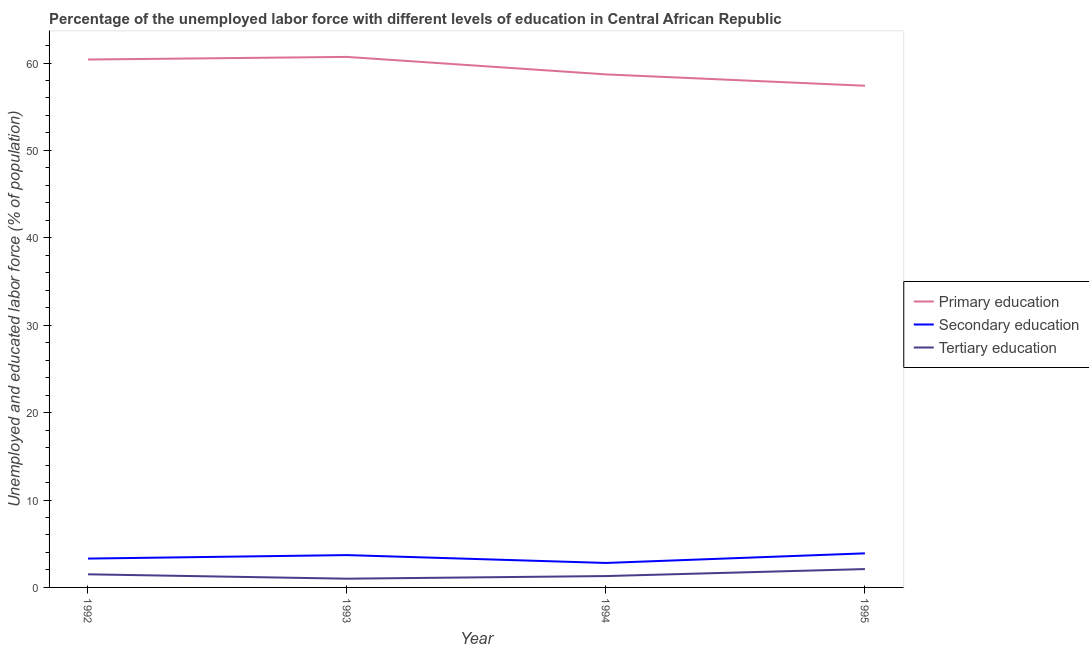Does the line corresponding to percentage of labor force who received tertiary education intersect with the line corresponding to percentage of labor force who received secondary education?
Your answer should be very brief. No. What is the percentage of labor force who received secondary education in 1994?
Give a very brief answer. 2.8. Across all years, what is the maximum percentage of labor force who received tertiary education?
Provide a short and direct response. 2.1. Across all years, what is the minimum percentage of labor force who received primary education?
Keep it short and to the point. 57.4. In which year was the percentage of labor force who received tertiary education maximum?
Ensure brevity in your answer.  1995. In which year was the percentage of labor force who received tertiary education minimum?
Your response must be concise. 1993. What is the total percentage of labor force who received primary education in the graph?
Your response must be concise. 237.2. What is the difference between the percentage of labor force who received primary education in 1993 and that in 1995?
Keep it short and to the point. 3.3. What is the difference between the percentage of labor force who received primary education in 1995 and the percentage of labor force who received tertiary education in 1994?
Provide a succinct answer. 56.1. What is the average percentage of labor force who received secondary education per year?
Provide a succinct answer. 3.43. In the year 1993, what is the difference between the percentage of labor force who received tertiary education and percentage of labor force who received secondary education?
Your answer should be very brief. -2.7. In how many years, is the percentage of labor force who received secondary education greater than 44 %?
Make the answer very short. 0. What is the ratio of the percentage of labor force who received primary education in 1994 to that in 1995?
Keep it short and to the point. 1.02. Is the percentage of labor force who received tertiary education in 1992 less than that in 1993?
Ensure brevity in your answer.  No. Is the difference between the percentage of labor force who received secondary education in 1994 and 1995 greater than the difference between the percentage of labor force who received tertiary education in 1994 and 1995?
Offer a very short reply. No. What is the difference between the highest and the second highest percentage of labor force who received secondary education?
Give a very brief answer. 0.2. What is the difference between the highest and the lowest percentage of labor force who received secondary education?
Provide a short and direct response. 1.1. Is the sum of the percentage of labor force who received secondary education in 1992 and 1995 greater than the maximum percentage of labor force who received tertiary education across all years?
Give a very brief answer. Yes. Is it the case that in every year, the sum of the percentage of labor force who received primary education and percentage of labor force who received secondary education is greater than the percentage of labor force who received tertiary education?
Give a very brief answer. Yes. Does the percentage of labor force who received primary education monotonically increase over the years?
Provide a short and direct response. No. Is the percentage of labor force who received secondary education strictly greater than the percentage of labor force who received tertiary education over the years?
Make the answer very short. Yes. Where does the legend appear in the graph?
Provide a succinct answer. Center right. How are the legend labels stacked?
Give a very brief answer. Vertical. What is the title of the graph?
Make the answer very short. Percentage of the unemployed labor force with different levels of education in Central African Republic. Does "Natural gas sources" appear as one of the legend labels in the graph?
Your response must be concise. No. What is the label or title of the X-axis?
Your response must be concise. Year. What is the label or title of the Y-axis?
Give a very brief answer. Unemployed and educated labor force (% of population). What is the Unemployed and educated labor force (% of population) in Primary education in 1992?
Provide a succinct answer. 60.4. What is the Unemployed and educated labor force (% of population) in Secondary education in 1992?
Provide a succinct answer. 3.3. What is the Unemployed and educated labor force (% of population) in Tertiary education in 1992?
Your answer should be very brief. 1.5. What is the Unemployed and educated labor force (% of population) in Primary education in 1993?
Give a very brief answer. 60.7. What is the Unemployed and educated labor force (% of population) in Secondary education in 1993?
Your response must be concise. 3.7. What is the Unemployed and educated labor force (% of population) of Primary education in 1994?
Ensure brevity in your answer.  58.7. What is the Unemployed and educated labor force (% of population) of Secondary education in 1994?
Offer a terse response. 2.8. What is the Unemployed and educated labor force (% of population) of Tertiary education in 1994?
Your answer should be compact. 1.3. What is the Unemployed and educated labor force (% of population) of Primary education in 1995?
Give a very brief answer. 57.4. What is the Unemployed and educated labor force (% of population) of Secondary education in 1995?
Offer a very short reply. 3.9. What is the Unemployed and educated labor force (% of population) in Tertiary education in 1995?
Your response must be concise. 2.1. Across all years, what is the maximum Unemployed and educated labor force (% of population) of Primary education?
Your answer should be very brief. 60.7. Across all years, what is the maximum Unemployed and educated labor force (% of population) in Secondary education?
Ensure brevity in your answer.  3.9. Across all years, what is the maximum Unemployed and educated labor force (% of population) of Tertiary education?
Give a very brief answer. 2.1. Across all years, what is the minimum Unemployed and educated labor force (% of population) in Primary education?
Provide a short and direct response. 57.4. Across all years, what is the minimum Unemployed and educated labor force (% of population) of Secondary education?
Make the answer very short. 2.8. What is the total Unemployed and educated labor force (% of population) of Primary education in the graph?
Make the answer very short. 237.2. What is the total Unemployed and educated labor force (% of population) in Secondary education in the graph?
Give a very brief answer. 13.7. What is the total Unemployed and educated labor force (% of population) in Tertiary education in the graph?
Offer a very short reply. 5.9. What is the difference between the Unemployed and educated labor force (% of population) in Primary education in 1992 and that in 1993?
Your answer should be compact. -0.3. What is the difference between the Unemployed and educated labor force (% of population) in Primary education in 1992 and that in 1995?
Your response must be concise. 3. What is the difference between the Unemployed and educated labor force (% of population) of Primary education in 1993 and that in 1994?
Your answer should be compact. 2. What is the difference between the Unemployed and educated labor force (% of population) of Tertiary education in 1993 and that in 1994?
Keep it short and to the point. -0.3. What is the difference between the Unemployed and educated labor force (% of population) in Primary education in 1993 and that in 1995?
Ensure brevity in your answer.  3.3. What is the difference between the Unemployed and educated labor force (% of population) of Secondary education in 1994 and that in 1995?
Your answer should be compact. -1.1. What is the difference between the Unemployed and educated labor force (% of population) of Primary education in 1992 and the Unemployed and educated labor force (% of population) of Secondary education in 1993?
Offer a very short reply. 56.7. What is the difference between the Unemployed and educated labor force (% of population) of Primary education in 1992 and the Unemployed and educated labor force (% of population) of Tertiary education in 1993?
Ensure brevity in your answer.  59.4. What is the difference between the Unemployed and educated labor force (% of population) of Secondary education in 1992 and the Unemployed and educated labor force (% of population) of Tertiary education in 1993?
Provide a short and direct response. 2.3. What is the difference between the Unemployed and educated labor force (% of population) in Primary education in 1992 and the Unemployed and educated labor force (% of population) in Secondary education in 1994?
Provide a succinct answer. 57.6. What is the difference between the Unemployed and educated labor force (% of population) of Primary education in 1992 and the Unemployed and educated labor force (% of population) of Tertiary education in 1994?
Give a very brief answer. 59.1. What is the difference between the Unemployed and educated labor force (% of population) of Secondary education in 1992 and the Unemployed and educated labor force (% of population) of Tertiary education in 1994?
Offer a terse response. 2. What is the difference between the Unemployed and educated labor force (% of population) in Primary education in 1992 and the Unemployed and educated labor force (% of population) in Secondary education in 1995?
Give a very brief answer. 56.5. What is the difference between the Unemployed and educated labor force (% of population) in Primary education in 1992 and the Unemployed and educated labor force (% of population) in Tertiary education in 1995?
Your answer should be compact. 58.3. What is the difference between the Unemployed and educated labor force (% of population) in Secondary education in 1992 and the Unemployed and educated labor force (% of population) in Tertiary education in 1995?
Provide a short and direct response. 1.2. What is the difference between the Unemployed and educated labor force (% of population) of Primary education in 1993 and the Unemployed and educated labor force (% of population) of Secondary education in 1994?
Offer a terse response. 57.9. What is the difference between the Unemployed and educated labor force (% of population) in Primary education in 1993 and the Unemployed and educated labor force (% of population) in Tertiary education in 1994?
Offer a very short reply. 59.4. What is the difference between the Unemployed and educated labor force (% of population) of Secondary education in 1993 and the Unemployed and educated labor force (% of population) of Tertiary education in 1994?
Offer a very short reply. 2.4. What is the difference between the Unemployed and educated labor force (% of population) of Primary education in 1993 and the Unemployed and educated labor force (% of population) of Secondary education in 1995?
Ensure brevity in your answer.  56.8. What is the difference between the Unemployed and educated labor force (% of population) of Primary education in 1993 and the Unemployed and educated labor force (% of population) of Tertiary education in 1995?
Make the answer very short. 58.6. What is the difference between the Unemployed and educated labor force (% of population) in Secondary education in 1993 and the Unemployed and educated labor force (% of population) in Tertiary education in 1995?
Offer a very short reply. 1.6. What is the difference between the Unemployed and educated labor force (% of population) in Primary education in 1994 and the Unemployed and educated labor force (% of population) in Secondary education in 1995?
Your answer should be very brief. 54.8. What is the difference between the Unemployed and educated labor force (% of population) of Primary education in 1994 and the Unemployed and educated labor force (% of population) of Tertiary education in 1995?
Make the answer very short. 56.6. What is the average Unemployed and educated labor force (% of population) in Primary education per year?
Your answer should be very brief. 59.3. What is the average Unemployed and educated labor force (% of population) in Secondary education per year?
Keep it short and to the point. 3.42. What is the average Unemployed and educated labor force (% of population) in Tertiary education per year?
Provide a succinct answer. 1.48. In the year 1992, what is the difference between the Unemployed and educated labor force (% of population) in Primary education and Unemployed and educated labor force (% of population) in Secondary education?
Provide a succinct answer. 57.1. In the year 1992, what is the difference between the Unemployed and educated labor force (% of population) of Primary education and Unemployed and educated labor force (% of population) of Tertiary education?
Offer a very short reply. 58.9. In the year 1992, what is the difference between the Unemployed and educated labor force (% of population) in Secondary education and Unemployed and educated labor force (% of population) in Tertiary education?
Your answer should be very brief. 1.8. In the year 1993, what is the difference between the Unemployed and educated labor force (% of population) of Primary education and Unemployed and educated labor force (% of population) of Secondary education?
Your answer should be very brief. 57. In the year 1993, what is the difference between the Unemployed and educated labor force (% of population) in Primary education and Unemployed and educated labor force (% of population) in Tertiary education?
Offer a terse response. 59.7. In the year 1993, what is the difference between the Unemployed and educated labor force (% of population) of Secondary education and Unemployed and educated labor force (% of population) of Tertiary education?
Provide a short and direct response. 2.7. In the year 1994, what is the difference between the Unemployed and educated labor force (% of population) in Primary education and Unemployed and educated labor force (% of population) in Secondary education?
Provide a succinct answer. 55.9. In the year 1994, what is the difference between the Unemployed and educated labor force (% of population) of Primary education and Unemployed and educated labor force (% of population) of Tertiary education?
Keep it short and to the point. 57.4. In the year 1995, what is the difference between the Unemployed and educated labor force (% of population) in Primary education and Unemployed and educated labor force (% of population) in Secondary education?
Your answer should be compact. 53.5. In the year 1995, what is the difference between the Unemployed and educated labor force (% of population) in Primary education and Unemployed and educated labor force (% of population) in Tertiary education?
Ensure brevity in your answer.  55.3. In the year 1995, what is the difference between the Unemployed and educated labor force (% of population) in Secondary education and Unemployed and educated labor force (% of population) in Tertiary education?
Offer a very short reply. 1.8. What is the ratio of the Unemployed and educated labor force (% of population) of Primary education in 1992 to that in 1993?
Provide a short and direct response. 1. What is the ratio of the Unemployed and educated labor force (% of population) of Secondary education in 1992 to that in 1993?
Make the answer very short. 0.89. What is the ratio of the Unemployed and educated labor force (% of population) of Tertiary education in 1992 to that in 1993?
Provide a succinct answer. 1.5. What is the ratio of the Unemployed and educated labor force (% of population) of Secondary education in 1992 to that in 1994?
Your response must be concise. 1.18. What is the ratio of the Unemployed and educated labor force (% of population) of Tertiary education in 1992 to that in 1994?
Offer a terse response. 1.15. What is the ratio of the Unemployed and educated labor force (% of population) of Primary education in 1992 to that in 1995?
Your answer should be compact. 1.05. What is the ratio of the Unemployed and educated labor force (% of population) of Secondary education in 1992 to that in 1995?
Provide a short and direct response. 0.85. What is the ratio of the Unemployed and educated labor force (% of population) in Tertiary education in 1992 to that in 1995?
Provide a succinct answer. 0.71. What is the ratio of the Unemployed and educated labor force (% of population) in Primary education in 1993 to that in 1994?
Provide a short and direct response. 1.03. What is the ratio of the Unemployed and educated labor force (% of population) of Secondary education in 1993 to that in 1994?
Provide a succinct answer. 1.32. What is the ratio of the Unemployed and educated labor force (% of population) of Tertiary education in 1993 to that in 1994?
Provide a succinct answer. 0.77. What is the ratio of the Unemployed and educated labor force (% of population) in Primary education in 1993 to that in 1995?
Provide a short and direct response. 1.06. What is the ratio of the Unemployed and educated labor force (% of population) in Secondary education in 1993 to that in 1995?
Provide a short and direct response. 0.95. What is the ratio of the Unemployed and educated labor force (% of population) of Tertiary education in 1993 to that in 1995?
Your answer should be very brief. 0.48. What is the ratio of the Unemployed and educated labor force (% of population) in Primary education in 1994 to that in 1995?
Give a very brief answer. 1.02. What is the ratio of the Unemployed and educated labor force (% of population) of Secondary education in 1994 to that in 1995?
Your answer should be compact. 0.72. What is the ratio of the Unemployed and educated labor force (% of population) of Tertiary education in 1994 to that in 1995?
Your response must be concise. 0.62. What is the difference between the highest and the second highest Unemployed and educated labor force (% of population) of Primary education?
Offer a terse response. 0.3. What is the difference between the highest and the second highest Unemployed and educated labor force (% of population) of Secondary education?
Make the answer very short. 0.2. What is the difference between the highest and the second highest Unemployed and educated labor force (% of population) in Tertiary education?
Your response must be concise. 0.6. What is the difference between the highest and the lowest Unemployed and educated labor force (% of population) in Secondary education?
Provide a succinct answer. 1.1. 